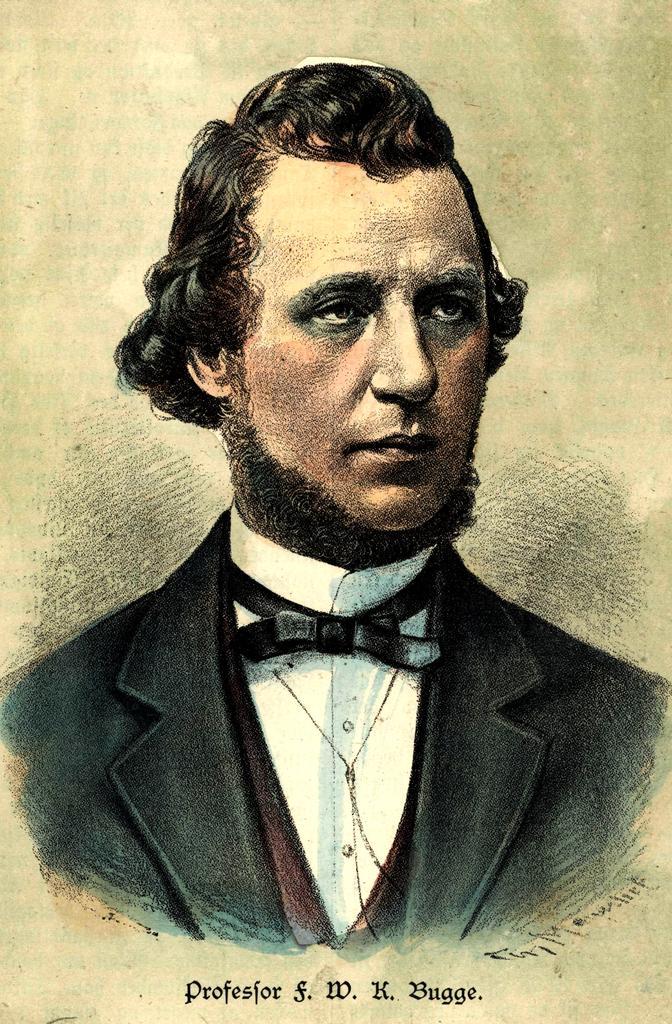Describe this image in one or two sentences. In this image I can see a painting of a man. Here I can see a watermark. 